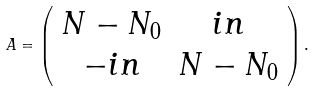<formula> <loc_0><loc_0><loc_500><loc_500>A = \left ( \begin{array} { c c } N - N _ { 0 } & i n \\ - i n & N - N _ { 0 } \end{array} \right ) .</formula> 